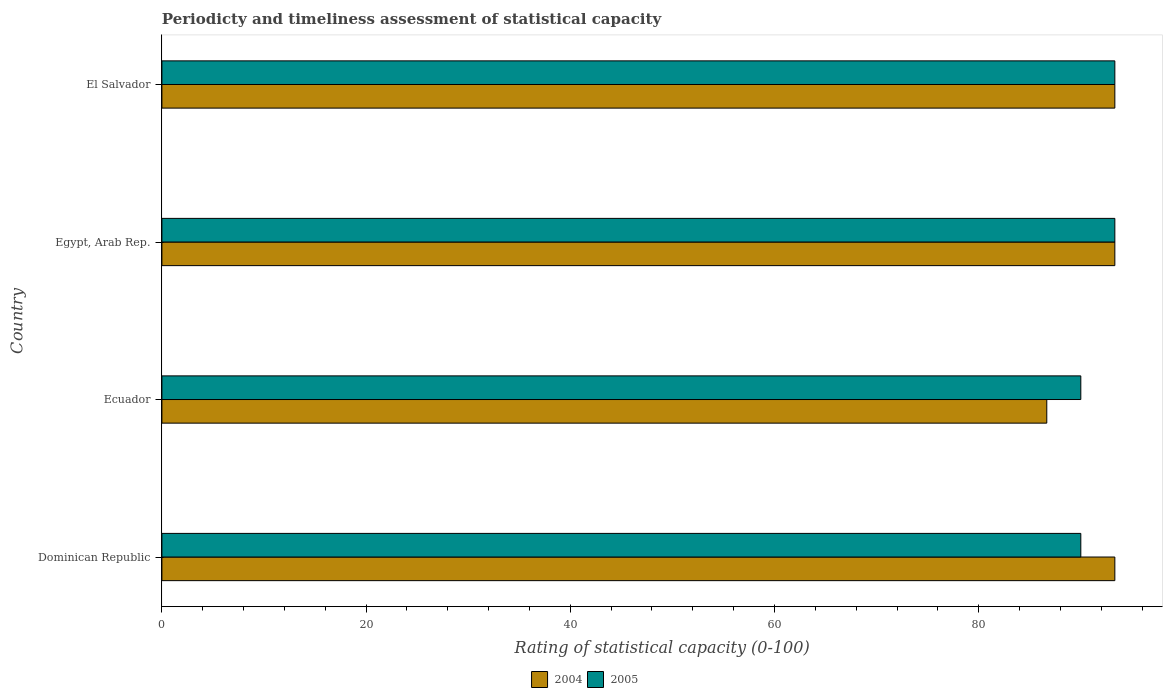How many groups of bars are there?
Provide a short and direct response. 4. Are the number of bars per tick equal to the number of legend labels?
Offer a very short reply. Yes. How many bars are there on the 4th tick from the top?
Provide a short and direct response. 2. How many bars are there on the 1st tick from the bottom?
Offer a terse response. 2. What is the label of the 2nd group of bars from the top?
Keep it short and to the point. Egypt, Arab Rep. In how many cases, is the number of bars for a given country not equal to the number of legend labels?
Your answer should be very brief. 0. Across all countries, what is the maximum rating of statistical capacity in 2005?
Your response must be concise. 93.33. In which country was the rating of statistical capacity in 2005 maximum?
Your answer should be compact. Egypt, Arab Rep. In which country was the rating of statistical capacity in 2005 minimum?
Your answer should be very brief. Dominican Republic. What is the total rating of statistical capacity in 2004 in the graph?
Ensure brevity in your answer.  366.67. What is the difference between the rating of statistical capacity in 2004 in Dominican Republic and that in Ecuador?
Make the answer very short. 6.67. What is the difference between the rating of statistical capacity in 2005 in Ecuador and the rating of statistical capacity in 2004 in Dominican Republic?
Make the answer very short. -3.33. What is the average rating of statistical capacity in 2005 per country?
Your response must be concise. 91.67. In how many countries, is the rating of statistical capacity in 2005 greater than 56 ?
Make the answer very short. 4. What is the ratio of the rating of statistical capacity in 2005 in Dominican Republic to that in El Salvador?
Make the answer very short. 0.96. Is the rating of statistical capacity in 2004 in Dominican Republic less than that in El Salvador?
Give a very brief answer. No. What is the difference between the highest and the second highest rating of statistical capacity in 2005?
Provide a short and direct response. 0. What is the difference between the highest and the lowest rating of statistical capacity in 2005?
Provide a short and direct response. 3.33. Is the sum of the rating of statistical capacity in 2005 in Egypt, Arab Rep. and El Salvador greater than the maximum rating of statistical capacity in 2004 across all countries?
Make the answer very short. Yes. Are all the bars in the graph horizontal?
Make the answer very short. Yes. Are the values on the major ticks of X-axis written in scientific E-notation?
Your answer should be compact. No. Does the graph contain grids?
Make the answer very short. No. Where does the legend appear in the graph?
Provide a short and direct response. Bottom center. How many legend labels are there?
Keep it short and to the point. 2. How are the legend labels stacked?
Your response must be concise. Horizontal. What is the title of the graph?
Your response must be concise. Periodicty and timeliness assessment of statistical capacity. What is the label or title of the X-axis?
Provide a succinct answer. Rating of statistical capacity (0-100). What is the label or title of the Y-axis?
Offer a terse response. Country. What is the Rating of statistical capacity (0-100) of 2004 in Dominican Republic?
Give a very brief answer. 93.33. What is the Rating of statistical capacity (0-100) in 2004 in Ecuador?
Give a very brief answer. 86.67. What is the Rating of statistical capacity (0-100) of 2005 in Ecuador?
Provide a succinct answer. 90. What is the Rating of statistical capacity (0-100) of 2004 in Egypt, Arab Rep.?
Provide a short and direct response. 93.33. What is the Rating of statistical capacity (0-100) in 2005 in Egypt, Arab Rep.?
Your response must be concise. 93.33. What is the Rating of statistical capacity (0-100) of 2004 in El Salvador?
Your answer should be compact. 93.33. What is the Rating of statistical capacity (0-100) of 2005 in El Salvador?
Give a very brief answer. 93.33. Across all countries, what is the maximum Rating of statistical capacity (0-100) in 2004?
Offer a terse response. 93.33. Across all countries, what is the maximum Rating of statistical capacity (0-100) of 2005?
Provide a short and direct response. 93.33. Across all countries, what is the minimum Rating of statistical capacity (0-100) of 2004?
Provide a short and direct response. 86.67. Across all countries, what is the minimum Rating of statistical capacity (0-100) in 2005?
Give a very brief answer. 90. What is the total Rating of statistical capacity (0-100) of 2004 in the graph?
Provide a short and direct response. 366.67. What is the total Rating of statistical capacity (0-100) of 2005 in the graph?
Your answer should be compact. 366.67. What is the difference between the Rating of statistical capacity (0-100) in 2005 in Dominican Republic and that in Egypt, Arab Rep.?
Provide a succinct answer. -3.33. What is the difference between the Rating of statistical capacity (0-100) in 2004 in Dominican Republic and that in El Salvador?
Ensure brevity in your answer.  0. What is the difference between the Rating of statistical capacity (0-100) of 2005 in Dominican Republic and that in El Salvador?
Your answer should be compact. -3.33. What is the difference between the Rating of statistical capacity (0-100) of 2004 in Ecuador and that in Egypt, Arab Rep.?
Offer a very short reply. -6.67. What is the difference between the Rating of statistical capacity (0-100) in 2005 in Ecuador and that in Egypt, Arab Rep.?
Provide a short and direct response. -3.33. What is the difference between the Rating of statistical capacity (0-100) of 2004 in Ecuador and that in El Salvador?
Offer a very short reply. -6.67. What is the difference between the Rating of statistical capacity (0-100) in 2005 in Egypt, Arab Rep. and that in El Salvador?
Provide a succinct answer. 0. What is the difference between the Rating of statistical capacity (0-100) in 2004 in Dominican Republic and the Rating of statistical capacity (0-100) in 2005 in Ecuador?
Your answer should be very brief. 3.33. What is the difference between the Rating of statistical capacity (0-100) of 2004 in Ecuador and the Rating of statistical capacity (0-100) of 2005 in Egypt, Arab Rep.?
Your answer should be compact. -6.67. What is the difference between the Rating of statistical capacity (0-100) in 2004 in Ecuador and the Rating of statistical capacity (0-100) in 2005 in El Salvador?
Make the answer very short. -6.67. What is the average Rating of statistical capacity (0-100) in 2004 per country?
Your response must be concise. 91.67. What is the average Rating of statistical capacity (0-100) of 2005 per country?
Offer a terse response. 91.67. What is the difference between the Rating of statistical capacity (0-100) of 2004 and Rating of statistical capacity (0-100) of 2005 in Dominican Republic?
Your response must be concise. 3.33. What is the difference between the Rating of statistical capacity (0-100) in 2004 and Rating of statistical capacity (0-100) in 2005 in Ecuador?
Ensure brevity in your answer.  -3.33. What is the ratio of the Rating of statistical capacity (0-100) of 2004 in Dominican Republic to that in Ecuador?
Provide a short and direct response. 1.08. What is the ratio of the Rating of statistical capacity (0-100) in 2004 in Dominican Republic to that in Egypt, Arab Rep.?
Your response must be concise. 1. What is the ratio of the Rating of statistical capacity (0-100) in 2004 in Dominican Republic to that in El Salvador?
Provide a short and direct response. 1. What is the ratio of the Rating of statistical capacity (0-100) in 2005 in Dominican Republic to that in El Salvador?
Keep it short and to the point. 0.96. What is the ratio of the Rating of statistical capacity (0-100) of 2004 in Ecuador to that in Egypt, Arab Rep.?
Provide a short and direct response. 0.93. What is the ratio of the Rating of statistical capacity (0-100) of 2004 in Ecuador to that in El Salvador?
Provide a succinct answer. 0.93. What is the ratio of the Rating of statistical capacity (0-100) of 2004 in Egypt, Arab Rep. to that in El Salvador?
Your answer should be very brief. 1. What is the ratio of the Rating of statistical capacity (0-100) of 2005 in Egypt, Arab Rep. to that in El Salvador?
Give a very brief answer. 1. What is the difference between the highest and the second highest Rating of statistical capacity (0-100) of 2005?
Provide a succinct answer. 0. What is the difference between the highest and the lowest Rating of statistical capacity (0-100) of 2004?
Give a very brief answer. 6.67. 